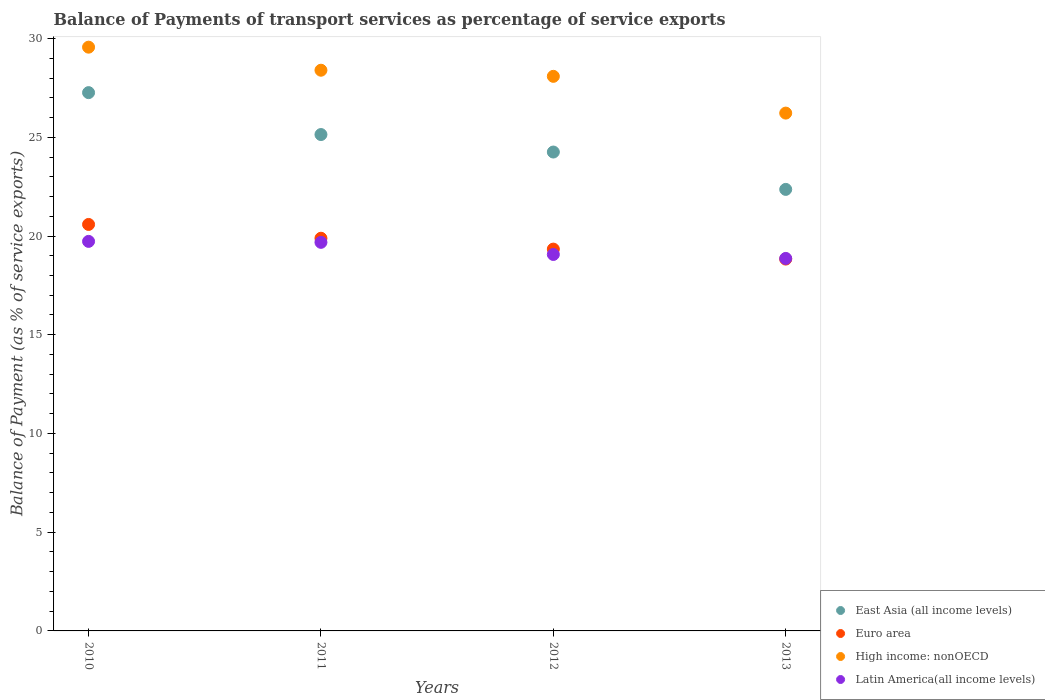How many different coloured dotlines are there?
Give a very brief answer. 4. What is the balance of payments of transport services in East Asia (all income levels) in 2013?
Ensure brevity in your answer.  22.36. Across all years, what is the maximum balance of payments of transport services in Latin America(all income levels)?
Keep it short and to the point. 19.73. Across all years, what is the minimum balance of payments of transport services in High income: nonOECD?
Your answer should be compact. 26.22. In which year was the balance of payments of transport services in East Asia (all income levels) maximum?
Make the answer very short. 2010. In which year was the balance of payments of transport services in East Asia (all income levels) minimum?
Make the answer very short. 2013. What is the total balance of payments of transport services in Euro area in the graph?
Provide a succinct answer. 78.64. What is the difference between the balance of payments of transport services in High income: nonOECD in 2010 and that in 2011?
Ensure brevity in your answer.  1.17. What is the difference between the balance of payments of transport services in East Asia (all income levels) in 2013 and the balance of payments of transport services in Latin America(all income levels) in 2010?
Give a very brief answer. 2.63. What is the average balance of payments of transport services in Latin America(all income levels) per year?
Provide a succinct answer. 19.33. In the year 2011, what is the difference between the balance of payments of transport services in High income: nonOECD and balance of payments of transport services in Euro area?
Provide a succinct answer. 8.51. What is the ratio of the balance of payments of transport services in Euro area in 2010 to that in 2011?
Keep it short and to the point. 1.04. Is the difference between the balance of payments of transport services in High income: nonOECD in 2010 and 2013 greater than the difference between the balance of payments of transport services in Euro area in 2010 and 2013?
Your answer should be compact. Yes. What is the difference between the highest and the second highest balance of payments of transport services in East Asia (all income levels)?
Make the answer very short. 2.12. What is the difference between the highest and the lowest balance of payments of transport services in High income: nonOECD?
Ensure brevity in your answer.  3.34. In how many years, is the balance of payments of transport services in Euro area greater than the average balance of payments of transport services in Euro area taken over all years?
Ensure brevity in your answer.  2. Is the sum of the balance of payments of transport services in Latin America(all income levels) in 2012 and 2013 greater than the maximum balance of payments of transport services in High income: nonOECD across all years?
Keep it short and to the point. Yes. Is the balance of payments of transport services in High income: nonOECD strictly greater than the balance of payments of transport services in Euro area over the years?
Your response must be concise. Yes. Is the balance of payments of transport services in East Asia (all income levels) strictly less than the balance of payments of transport services in Latin America(all income levels) over the years?
Offer a terse response. No. How many years are there in the graph?
Keep it short and to the point. 4. Are the values on the major ticks of Y-axis written in scientific E-notation?
Provide a succinct answer. No. Does the graph contain any zero values?
Your answer should be compact. No. What is the title of the graph?
Ensure brevity in your answer.  Balance of Payments of transport services as percentage of service exports. What is the label or title of the Y-axis?
Your answer should be compact. Balance of Payment (as % of service exports). What is the Balance of Payment (as % of service exports) of East Asia (all income levels) in 2010?
Give a very brief answer. 27.26. What is the Balance of Payment (as % of service exports) in Euro area in 2010?
Offer a terse response. 20.59. What is the Balance of Payment (as % of service exports) of High income: nonOECD in 2010?
Keep it short and to the point. 29.56. What is the Balance of Payment (as % of service exports) in Latin America(all income levels) in 2010?
Offer a very short reply. 19.73. What is the Balance of Payment (as % of service exports) of East Asia (all income levels) in 2011?
Provide a succinct answer. 25.14. What is the Balance of Payment (as % of service exports) in Euro area in 2011?
Your answer should be very brief. 19.89. What is the Balance of Payment (as % of service exports) of High income: nonOECD in 2011?
Your answer should be very brief. 28.4. What is the Balance of Payment (as % of service exports) in Latin America(all income levels) in 2011?
Your answer should be compact. 19.68. What is the Balance of Payment (as % of service exports) of East Asia (all income levels) in 2012?
Offer a terse response. 24.25. What is the Balance of Payment (as % of service exports) in Euro area in 2012?
Offer a terse response. 19.34. What is the Balance of Payment (as % of service exports) of High income: nonOECD in 2012?
Your answer should be very brief. 28.09. What is the Balance of Payment (as % of service exports) in Latin America(all income levels) in 2012?
Provide a short and direct response. 19.07. What is the Balance of Payment (as % of service exports) in East Asia (all income levels) in 2013?
Make the answer very short. 22.36. What is the Balance of Payment (as % of service exports) of Euro area in 2013?
Your answer should be very brief. 18.83. What is the Balance of Payment (as % of service exports) in High income: nonOECD in 2013?
Keep it short and to the point. 26.22. What is the Balance of Payment (as % of service exports) of Latin America(all income levels) in 2013?
Offer a very short reply. 18.86. Across all years, what is the maximum Balance of Payment (as % of service exports) in East Asia (all income levels)?
Provide a succinct answer. 27.26. Across all years, what is the maximum Balance of Payment (as % of service exports) in Euro area?
Ensure brevity in your answer.  20.59. Across all years, what is the maximum Balance of Payment (as % of service exports) of High income: nonOECD?
Offer a very short reply. 29.56. Across all years, what is the maximum Balance of Payment (as % of service exports) of Latin America(all income levels)?
Offer a very short reply. 19.73. Across all years, what is the minimum Balance of Payment (as % of service exports) in East Asia (all income levels)?
Your response must be concise. 22.36. Across all years, what is the minimum Balance of Payment (as % of service exports) of Euro area?
Offer a very short reply. 18.83. Across all years, what is the minimum Balance of Payment (as % of service exports) in High income: nonOECD?
Give a very brief answer. 26.22. Across all years, what is the minimum Balance of Payment (as % of service exports) in Latin America(all income levels)?
Ensure brevity in your answer.  18.86. What is the total Balance of Payment (as % of service exports) of East Asia (all income levels) in the graph?
Give a very brief answer. 99.01. What is the total Balance of Payment (as % of service exports) of Euro area in the graph?
Make the answer very short. 78.64. What is the total Balance of Payment (as % of service exports) of High income: nonOECD in the graph?
Ensure brevity in your answer.  112.27. What is the total Balance of Payment (as % of service exports) in Latin America(all income levels) in the graph?
Ensure brevity in your answer.  77.34. What is the difference between the Balance of Payment (as % of service exports) of East Asia (all income levels) in 2010 and that in 2011?
Your answer should be very brief. 2.12. What is the difference between the Balance of Payment (as % of service exports) in Euro area in 2010 and that in 2011?
Provide a succinct answer. 0.7. What is the difference between the Balance of Payment (as % of service exports) in High income: nonOECD in 2010 and that in 2011?
Provide a short and direct response. 1.17. What is the difference between the Balance of Payment (as % of service exports) in Latin America(all income levels) in 2010 and that in 2011?
Keep it short and to the point. 0.05. What is the difference between the Balance of Payment (as % of service exports) of East Asia (all income levels) in 2010 and that in 2012?
Keep it short and to the point. 3.01. What is the difference between the Balance of Payment (as % of service exports) of Euro area in 2010 and that in 2012?
Your answer should be compact. 1.25. What is the difference between the Balance of Payment (as % of service exports) in High income: nonOECD in 2010 and that in 2012?
Keep it short and to the point. 1.48. What is the difference between the Balance of Payment (as % of service exports) in Latin America(all income levels) in 2010 and that in 2012?
Your answer should be very brief. 0.66. What is the difference between the Balance of Payment (as % of service exports) of East Asia (all income levels) in 2010 and that in 2013?
Provide a short and direct response. 4.9. What is the difference between the Balance of Payment (as % of service exports) of Euro area in 2010 and that in 2013?
Make the answer very short. 1.75. What is the difference between the Balance of Payment (as % of service exports) in High income: nonOECD in 2010 and that in 2013?
Give a very brief answer. 3.34. What is the difference between the Balance of Payment (as % of service exports) of Latin America(all income levels) in 2010 and that in 2013?
Provide a succinct answer. 0.86. What is the difference between the Balance of Payment (as % of service exports) of East Asia (all income levels) in 2011 and that in 2012?
Make the answer very short. 0.89. What is the difference between the Balance of Payment (as % of service exports) of Euro area in 2011 and that in 2012?
Give a very brief answer. 0.55. What is the difference between the Balance of Payment (as % of service exports) of High income: nonOECD in 2011 and that in 2012?
Provide a short and direct response. 0.31. What is the difference between the Balance of Payment (as % of service exports) of Latin America(all income levels) in 2011 and that in 2012?
Keep it short and to the point. 0.61. What is the difference between the Balance of Payment (as % of service exports) of East Asia (all income levels) in 2011 and that in 2013?
Keep it short and to the point. 2.78. What is the difference between the Balance of Payment (as % of service exports) of Euro area in 2011 and that in 2013?
Your answer should be very brief. 1.06. What is the difference between the Balance of Payment (as % of service exports) of High income: nonOECD in 2011 and that in 2013?
Your response must be concise. 2.17. What is the difference between the Balance of Payment (as % of service exports) in Latin America(all income levels) in 2011 and that in 2013?
Keep it short and to the point. 0.81. What is the difference between the Balance of Payment (as % of service exports) in East Asia (all income levels) in 2012 and that in 2013?
Ensure brevity in your answer.  1.89. What is the difference between the Balance of Payment (as % of service exports) of Euro area in 2012 and that in 2013?
Offer a very short reply. 0.51. What is the difference between the Balance of Payment (as % of service exports) in High income: nonOECD in 2012 and that in 2013?
Your response must be concise. 1.86. What is the difference between the Balance of Payment (as % of service exports) in Latin America(all income levels) in 2012 and that in 2013?
Offer a terse response. 0.2. What is the difference between the Balance of Payment (as % of service exports) in East Asia (all income levels) in 2010 and the Balance of Payment (as % of service exports) in Euro area in 2011?
Offer a terse response. 7.37. What is the difference between the Balance of Payment (as % of service exports) of East Asia (all income levels) in 2010 and the Balance of Payment (as % of service exports) of High income: nonOECD in 2011?
Make the answer very short. -1.13. What is the difference between the Balance of Payment (as % of service exports) in East Asia (all income levels) in 2010 and the Balance of Payment (as % of service exports) in Latin America(all income levels) in 2011?
Your answer should be compact. 7.58. What is the difference between the Balance of Payment (as % of service exports) of Euro area in 2010 and the Balance of Payment (as % of service exports) of High income: nonOECD in 2011?
Your answer should be compact. -7.81. What is the difference between the Balance of Payment (as % of service exports) of Euro area in 2010 and the Balance of Payment (as % of service exports) of Latin America(all income levels) in 2011?
Your answer should be very brief. 0.91. What is the difference between the Balance of Payment (as % of service exports) of High income: nonOECD in 2010 and the Balance of Payment (as % of service exports) of Latin America(all income levels) in 2011?
Make the answer very short. 9.88. What is the difference between the Balance of Payment (as % of service exports) of East Asia (all income levels) in 2010 and the Balance of Payment (as % of service exports) of Euro area in 2012?
Keep it short and to the point. 7.92. What is the difference between the Balance of Payment (as % of service exports) in East Asia (all income levels) in 2010 and the Balance of Payment (as % of service exports) in High income: nonOECD in 2012?
Your answer should be compact. -0.82. What is the difference between the Balance of Payment (as % of service exports) of East Asia (all income levels) in 2010 and the Balance of Payment (as % of service exports) of Latin America(all income levels) in 2012?
Offer a very short reply. 8.2. What is the difference between the Balance of Payment (as % of service exports) of Euro area in 2010 and the Balance of Payment (as % of service exports) of High income: nonOECD in 2012?
Your answer should be very brief. -7.5. What is the difference between the Balance of Payment (as % of service exports) in Euro area in 2010 and the Balance of Payment (as % of service exports) in Latin America(all income levels) in 2012?
Make the answer very short. 1.52. What is the difference between the Balance of Payment (as % of service exports) in High income: nonOECD in 2010 and the Balance of Payment (as % of service exports) in Latin America(all income levels) in 2012?
Provide a succinct answer. 10.5. What is the difference between the Balance of Payment (as % of service exports) of East Asia (all income levels) in 2010 and the Balance of Payment (as % of service exports) of Euro area in 2013?
Offer a very short reply. 8.43. What is the difference between the Balance of Payment (as % of service exports) in East Asia (all income levels) in 2010 and the Balance of Payment (as % of service exports) in Latin America(all income levels) in 2013?
Provide a succinct answer. 8.4. What is the difference between the Balance of Payment (as % of service exports) in Euro area in 2010 and the Balance of Payment (as % of service exports) in High income: nonOECD in 2013?
Your answer should be compact. -5.64. What is the difference between the Balance of Payment (as % of service exports) of Euro area in 2010 and the Balance of Payment (as % of service exports) of Latin America(all income levels) in 2013?
Make the answer very short. 1.72. What is the difference between the Balance of Payment (as % of service exports) of High income: nonOECD in 2010 and the Balance of Payment (as % of service exports) of Latin America(all income levels) in 2013?
Your response must be concise. 10.7. What is the difference between the Balance of Payment (as % of service exports) of East Asia (all income levels) in 2011 and the Balance of Payment (as % of service exports) of Euro area in 2012?
Your response must be concise. 5.8. What is the difference between the Balance of Payment (as % of service exports) of East Asia (all income levels) in 2011 and the Balance of Payment (as % of service exports) of High income: nonOECD in 2012?
Provide a succinct answer. -2.95. What is the difference between the Balance of Payment (as % of service exports) in East Asia (all income levels) in 2011 and the Balance of Payment (as % of service exports) in Latin America(all income levels) in 2012?
Keep it short and to the point. 6.07. What is the difference between the Balance of Payment (as % of service exports) of Euro area in 2011 and the Balance of Payment (as % of service exports) of High income: nonOECD in 2012?
Your answer should be very brief. -8.2. What is the difference between the Balance of Payment (as % of service exports) of Euro area in 2011 and the Balance of Payment (as % of service exports) of Latin America(all income levels) in 2012?
Ensure brevity in your answer.  0.82. What is the difference between the Balance of Payment (as % of service exports) of High income: nonOECD in 2011 and the Balance of Payment (as % of service exports) of Latin America(all income levels) in 2012?
Keep it short and to the point. 9.33. What is the difference between the Balance of Payment (as % of service exports) in East Asia (all income levels) in 2011 and the Balance of Payment (as % of service exports) in Euro area in 2013?
Provide a succinct answer. 6.31. What is the difference between the Balance of Payment (as % of service exports) in East Asia (all income levels) in 2011 and the Balance of Payment (as % of service exports) in High income: nonOECD in 2013?
Offer a terse response. -1.09. What is the difference between the Balance of Payment (as % of service exports) of East Asia (all income levels) in 2011 and the Balance of Payment (as % of service exports) of Latin America(all income levels) in 2013?
Ensure brevity in your answer.  6.27. What is the difference between the Balance of Payment (as % of service exports) in Euro area in 2011 and the Balance of Payment (as % of service exports) in High income: nonOECD in 2013?
Provide a short and direct response. -6.34. What is the difference between the Balance of Payment (as % of service exports) in Euro area in 2011 and the Balance of Payment (as % of service exports) in Latin America(all income levels) in 2013?
Give a very brief answer. 1.02. What is the difference between the Balance of Payment (as % of service exports) of High income: nonOECD in 2011 and the Balance of Payment (as % of service exports) of Latin America(all income levels) in 2013?
Your answer should be compact. 9.53. What is the difference between the Balance of Payment (as % of service exports) in East Asia (all income levels) in 2012 and the Balance of Payment (as % of service exports) in Euro area in 2013?
Keep it short and to the point. 5.42. What is the difference between the Balance of Payment (as % of service exports) in East Asia (all income levels) in 2012 and the Balance of Payment (as % of service exports) in High income: nonOECD in 2013?
Keep it short and to the point. -1.97. What is the difference between the Balance of Payment (as % of service exports) in East Asia (all income levels) in 2012 and the Balance of Payment (as % of service exports) in Latin America(all income levels) in 2013?
Your response must be concise. 5.39. What is the difference between the Balance of Payment (as % of service exports) in Euro area in 2012 and the Balance of Payment (as % of service exports) in High income: nonOECD in 2013?
Your answer should be very brief. -6.89. What is the difference between the Balance of Payment (as % of service exports) in Euro area in 2012 and the Balance of Payment (as % of service exports) in Latin America(all income levels) in 2013?
Give a very brief answer. 0.47. What is the difference between the Balance of Payment (as % of service exports) in High income: nonOECD in 2012 and the Balance of Payment (as % of service exports) in Latin America(all income levels) in 2013?
Keep it short and to the point. 9.22. What is the average Balance of Payment (as % of service exports) of East Asia (all income levels) per year?
Provide a short and direct response. 24.75. What is the average Balance of Payment (as % of service exports) in Euro area per year?
Provide a short and direct response. 19.66. What is the average Balance of Payment (as % of service exports) in High income: nonOECD per year?
Provide a short and direct response. 28.07. What is the average Balance of Payment (as % of service exports) in Latin America(all income levels) per year?
Your answer should be very brief. 19.33. In the year 2010, what is the difference between the Balance of Payment (as % of service exports) in East Asia (all income levels) and Balance of Payment (as % of service exports) in Euro area?
Your answer should be compact. 6.68. In the year 2010, what is the difference between the Balance of Payment (as % of service exports) of East Asia (all income levels) and Balance of Payment (as % of service exports) of High income: nonOECD?
Your answer should be very brief. -2.3. In the year 2010, what is the difference between the Balance of Payment (as % of service exports) in East Asia (all income levels) and Balance of Payment (as % of service exports) in Latin America(all income levels)?
Offer a terse response. 7.53. In the year 2010, what is the difference between the Balance of Payment (as % of service exports) of Euro area and Balance of Payment (as % of service exports) of High income: nonOECD?
Your answer should be very brief. -8.98. In the year 2010, what is the difference between the Balance of Payment (as % of service exports) of Euro area and Balance of Payment (as % of service exports) of Latin America(all income levels)?
Keep it short and to the point. 0.86. In the year 2010, what is the difference between the Balance of Payment (as % of service exports) in High income: nonOECD and Balance of Payment (as % of service exports) in Latin America(all income levels)?
Give a very brief answer. 9.84. In the year 2011, what is the difference between the Balance of Payment (as % of service exports) of East Asia (all income levels) and Balance of Payment (as % of service exports) of Euro area?
Your response must be concise. 5.25. In the year 2011, what is the difference between the Balance of Payment (as % of service exports) of East Asia (all income levels) and Balance of Payment (as % of service exports) of High income: nonOECD?
Your answer should be compact. -3.26. In the year 2011, what is the difference between the Balance of Payment (as % of service exports) of East Asia (all income levels) and Balance of Payment (as % of service exports) of Latin America(all income levels)?
Offer a very short reply. 5.46. In the year 2011, what is the difference between the Balance of Payment (as % of service exports) of Euro area and Balance of Payment (as % of service exports) of High income: nonOECD?
Offer a very short reply. -8.51. In the year 2011, what is the difference between the Balance of Payment (as % of service exports) of Euro area and Balance of Payment (as % of service exports) of Latin America(all income levels)?
Your answer should be very brief. 0.21. In the year 2011, what is the difference between the Balance of Payment (as % of service exports) of High income: nonOECD and Balance of Payment (as % of service exports) of Latin America(all income levels)?
Give a very brief answer. 8.72. In the year 2012, what is the difference between the Balance of Payment (as % of service exports) in East Asia (all income levels) and Balance of Payment (as % of service exports) in Euro area?
Offer a very short reply. 4.92. In the year 2012, what is the difference between the Balance of Payment (as % of service exports) of East Asia (all income levels) and Balance of Payment (as % of service exports) of High income: nonOECD?
Offer a terse response. -3.83. In the year 2012, what is the difference between the Balance of Payment (as % of service exports) in East Asia (all income levels) and Balance of Payment (as % of service exports) in Latin America(all income levels)?
Make the answer very short. 5.19. In the year 2012, what is the difference between the Balance of Payment (as % of service exports) in Euro area and Balance of Payment (as % of service exports) in High income: nonOECD?
Make the answer very short. -8.75. In the year 2012, what is the difference between the Balance of Payment (as % of service exports) of Euro area and Balance of Payment (as % of service exports) of Latin America(all income levels)?
Provide a succinct answer. 0.27. In the year 2012, what is the difference between the Balance of Payment (as % of service exports) in High income: nonOECD and Balance of Payment (as % of service exports) in Latin America(all income levels)?
Offer a terse response. 9.02. In the year 2013, what is the difference between the Balance of Payment (as % of service exports) of East Asia (all income levels) and Balance of Payment (as % of service exports) of Euro area?
Keep it short and to the point. 3.53. In the year 2013, what is the difference between the Balance of Payment (as % of service exports) of East Asia (all income levels) and Balance of Payment (as % of service exports) of High income: nonOECD?
Ensure brevity in your answer.  -3.86. In the year 2013, what is the difference between the Balance of Payment (as % of service exports) of East Asia (all income levels) and Balance of Payment (as % of service exports) of Latin America(all income levels)?
Give a very brief answer. 3.5. In the year 2013, what is the difference between the Balance of Payment (as % of service exports) of Euro area and Balance of Payment (as % of service exports) of High income: nonOECD?
Offer a terse response. -7.39. In the year 2013, what is the difference between the Balance of Payment (as % of service exports) of Euro area and Balance of Payment (as % of service exports) of Latin America(all income levels)?
Keep it short and to the point. -0.03. In the year 2013, what is the difference between the Balance of Payment (as % of service exports) of High income: nonOECD and Balance of Payment (as % of service exports) of Latin America(all income levels)?
Your answer should be very brief. 7.36. What is the ratio of the Balance of Payment (as % of service exports) in East Asia (all income levels) in 2010 to that in 2011?
Provide a succinct answer. 1.08. What is the ratio of the Balance of Payment (as % of service exports) of Euro area in 2010 to that in 2011?
Keep it short and to the point. 1.04. What is the ratio of the Balance of Payment (as % of service exports) in High income: nonOECD in 2010 to that in 2011?
Give a very brief answer. 1.04. What is the ratio of the Balance of Payment (as % of service exports) of Latin America(all income levels) in 2010 to that in 2011?
Your answer should be compact. 1. What is the ratio of the Balance of Payment (as % of service exports) in East Asia (all income levels) in 2010 to that in 2012?
Your answer should be compact. 1.12. What is the ratio of the Balance of Payment (as % of service exports) in Euro area in 2010 to that in 2012?
Offer a terse response. 1.06. What is the ratio of the Balance of Payment (as % of service exports) of High income: nonOECD in 2010 to that in 2012?
Your response must be concise. 1.05. What is the ratio of the Balance of Payment (as % of service exports) in Latin America(all income levels) in 2010 to that in 2012?
Your answer should be compact. 1.03. What is the ratio of the Balance of Payment (as % of service exports) of East Asia (all income levels) in 2010 to that in 2013?
Keep it short and to the point. 1.22. What is the ratio of the Balance of Payment (as % of service exports) in Euro area in 2010 to that in 2013?
Provide a succinct answer. 1.09. What is the ratio of the Balance of Payment (as % of service exports) of High income: nonOECD in 2010 to that in 2013?
Provide a short and direct response. 1.13. What is the ratio of the Balance of Payment (as % of service exports) of Latin America(all income levels) in 2010 to that in 2013?
Provide a succinct answer. 1.05. What is the ratio of the Balance of Payment (as % of service exports) in East Asia (all income levels) in 2011 to that in 2012?
Offer a terse response. 1.04. What is the ratio of the Balance of Payment (as % of service exports) in Euro area in 2011 to that in 2012?
Give a very brief answer. 1.03. What is the ratio of the Balance of Payment (as % of service exports) of Latin America(all income levels) in 2011 to that in 2012?
Your answer should be compact. 1.03. What is the ratio of the Balance of Payment (as % of service exports) of East Asia (all income levels) in 2011 to that in 2013?
Your answer should be very brief. 1.12. What is the ratio of the Balance of Payment (as % of service exports) in Euro area in 2011 to that in 2013?
Ensure brevity in your answer.  1.06. What is the ratio of the Balance of Payment (as % of service exports) in High income: nonOECD in 2011 to that in 2013?
Provide a succinct answer. 1.08. What is the ratio of the Balance of Payment (as % of service exports) in Latin America(all income levels) in 2011 to that in 2013?
Make the answer very short. 1.04. What is the ratio of the Balance of Payment (as % of service exports) of East Asia (all income levels) in 2012 to that in 2013?
Your answer should be compact. 1.08. What is the ratio of the Balance of Payment (as % of service exports) in Euro area in 2012 to that in 2013?
Provide a short and direct response. 1.03. What is the ratio of the Balance of Payment (as % of service exports) of High income: nonOECD in 2012 to that in 2013?
Your answer should be compact. 1.07. What is the ratio of the Balance of Payment (as % of service exports) in Latin America(all income levels) in 2012 to that in 2013?
Your answer should be very brief. 1.01. What is the difference between the highest and the second highest Balance of Payment (as % of service exports) in East Asia (all income levels)?
Offer a very short reply. 2.12. What is the difference between the highest and the second highest Balance of Payment (as % of service exports) of Euro area?
Your answer should be very brief. 0.7. What is the difference between the highest and the second highest Balance of Payment (as % of service exports) of High income: nonOECD?
Your response must be concise. 1.17. What is the difference between the highest and the second highest Balance of Payment (as % of service exports) in Latin America(all income levels)?
Offer a very short reply. 0.05. What is the difference between the highest and the lowest Balance of Payment (as % of service exports) in East Asia (all income levels)?
Give a very brief answer. 4.9. What is the difference between the highest and the lowest Balance of Payment (as % of service exports) of Euro area?
Your answer should be compact. 1.75. What is the difference between the highest and the lowest Balance of Payment (as % of service exports) in High income: nonOECD?
Offer a terse response. 3.34. What is the difference between the highest and the lowest Balance of Payment (as % of service exports) in Latin America(all income levels)?
Offer a very short reply. 0.86. 